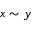Convert formula to latex. <formula><loc_0><loc_0><loc_500><loc_500>x \sim y</formula> 